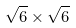Convert formula to latex. <formula><loc_0><loc_0><loc_500><loc_500>\sqrt { 6 } \times \sqrt { 6 }</formula> 